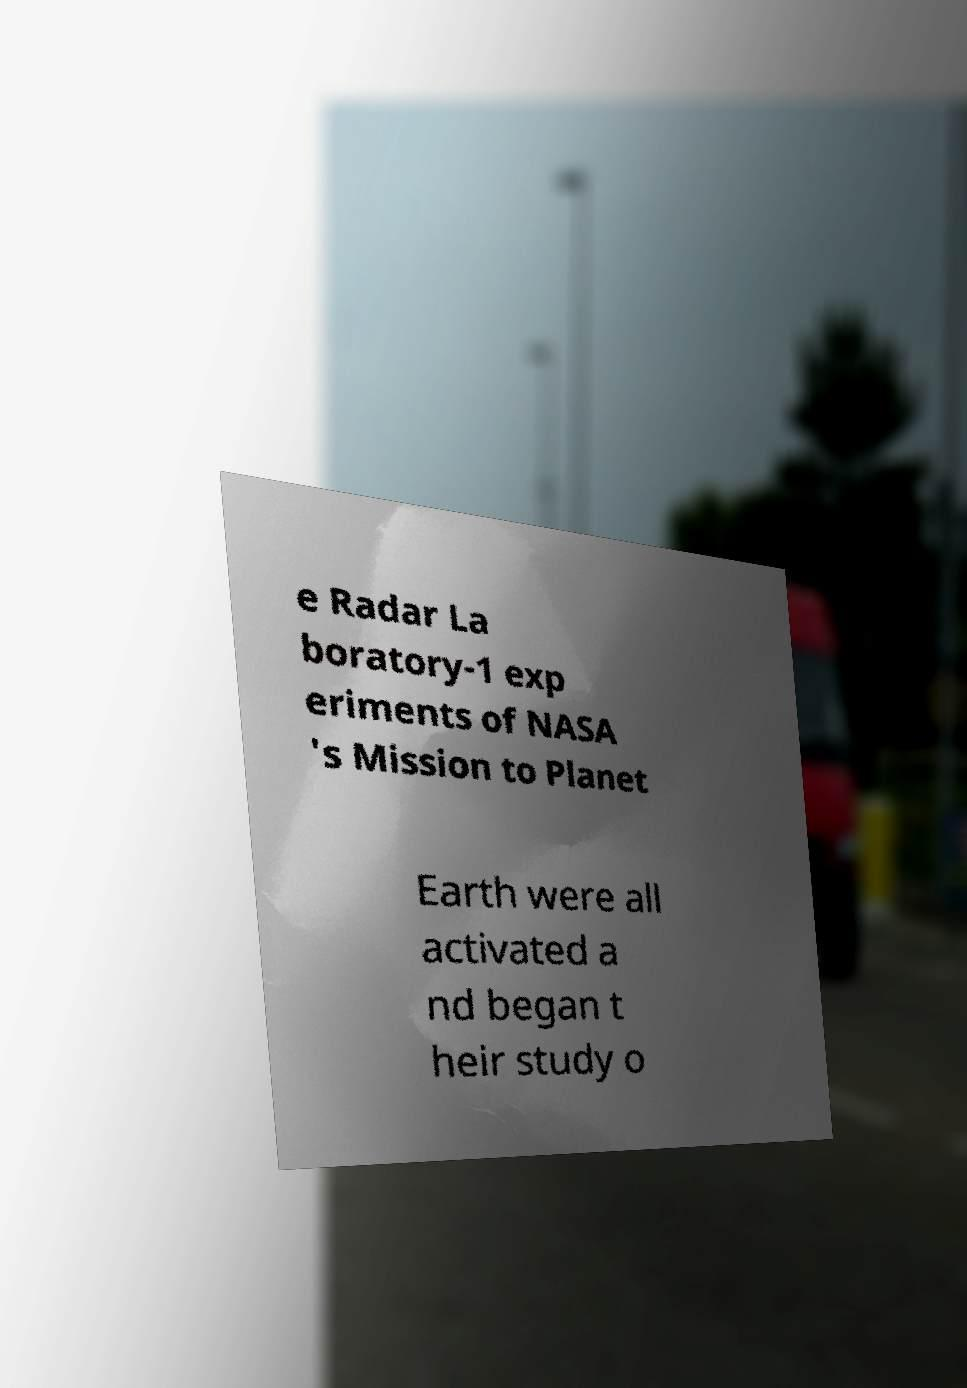Could you assist in decoding the text presented in this image and type it out clearly? e Radar La boratory-1 exp eriments of NASA 's Mission to Planet Earth were all activated a nd began t heir study o 